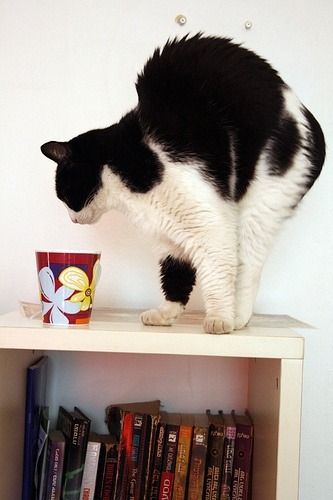Describe the objects in this image and their specific colors. I can see cat in lightgray, black, ivory, and tan tones, book in lightgray, black, maroon, and gray tones, and cup in lightgray, brown, and khaki tones in this image. 